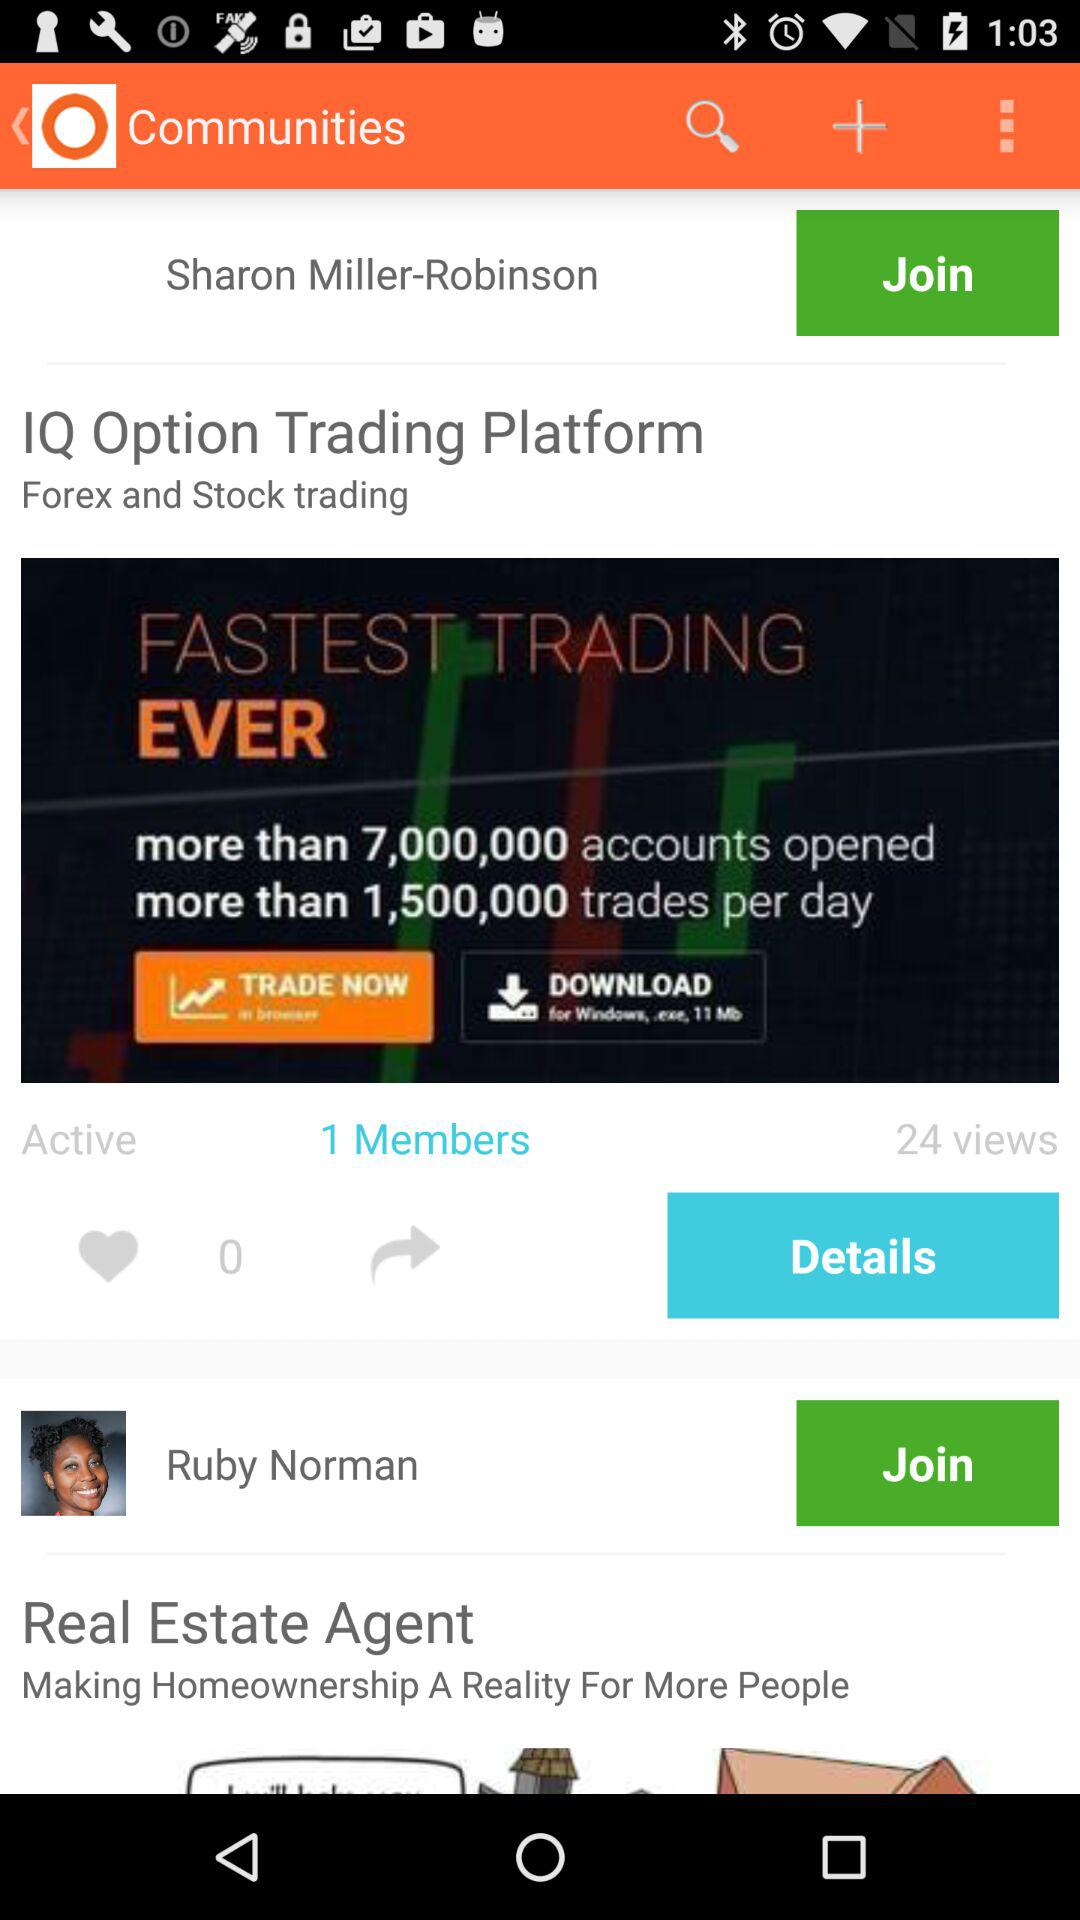What is the name of the person? The names of the people are Sharon Miller-Robinson and Ruby Norman. 